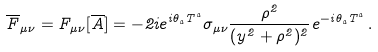Convert formula to latex. <formula><loc_0><loc_0><loc_500><loc_500>{ \overline { F } } _ { \mu \nu } = F _ { \mu \nu } [ { \overline { A } } ] = - 2 i e ^ { i \theta _ { a } T ^ { a } } \sigma _ { \mu \nu } \frac { \rho ^ { 2 } } { ( y ^ { 2 } + \rho ^ { 2 } ) ^ { 2 } } e ^ { - i \theta _ { a } T ^ { a } } \, .</formula> 